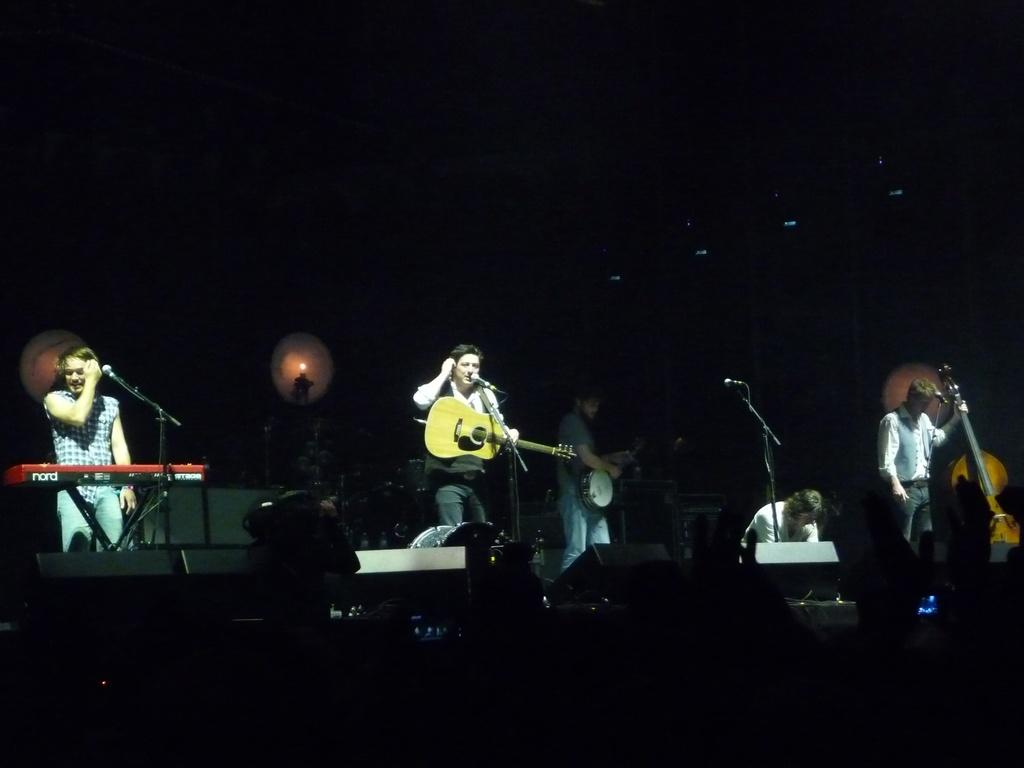How many people are in the image? There are people in the image, but the exact number is not specified. What are the people doing in the image? The people are standing and holding guitars in their hands. Can you describe the object in front of one of the people? There is a person standing in front of a Casio. What color is the chicken in the image? There is no chicken present in the image. What substance is being played by the people in the image? The facts do not mention any substance being played; the people are holding guitars, which are musical instruments. 